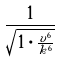<formula> <loc_0><loc_0><loc_500><loc_500>\frac { 1 } { \sqrt { 1 \cdot \frac { v ^ { 6 } } { k ^ { 6 } } } }</formula> 